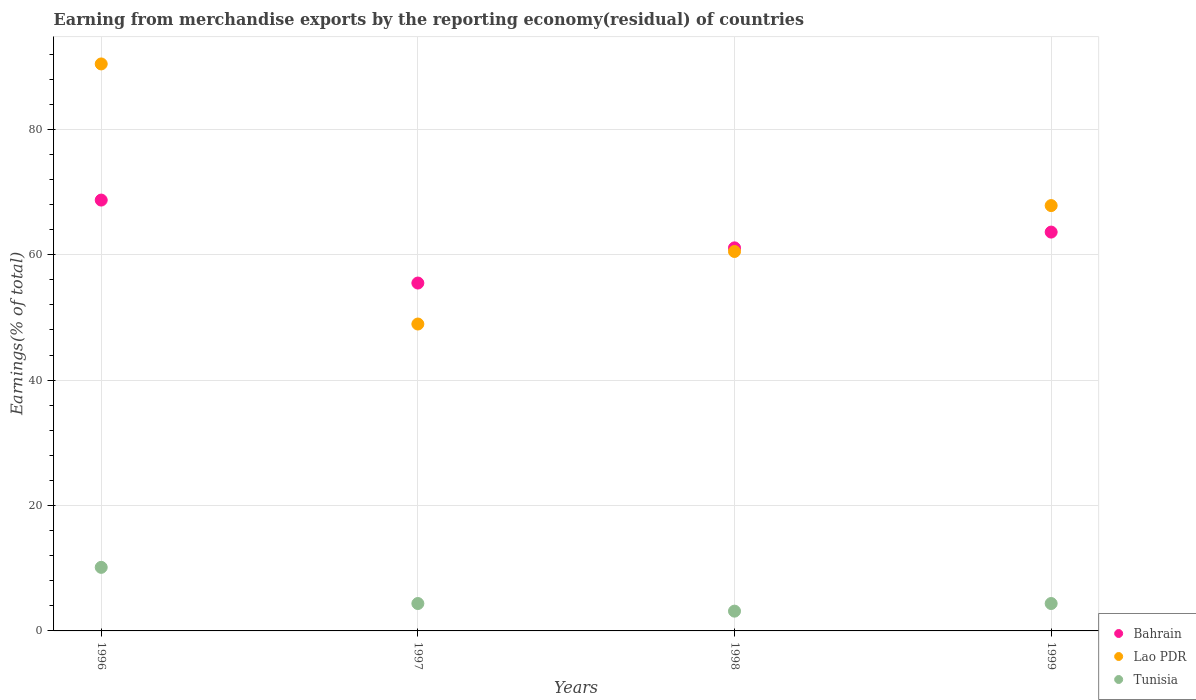What is the percentage of amount earned from merchandise exports in Lao PDR in 1996?
Your answer should be very brief. 90.43. Across all years, what is the maximum percentage of amount earned from merchandise exports in Lao PDR?
Your answer should be compact. 90.43. Across all years, what is the minimum percentage of amount earned from merchandise exports in Lao PDR?
Your answer should be very brief. 48.95. In which year was the percentage of amount earned from merchandise exports in Bahrain maximum?
Make the answer very short. 1996. In which year was the percentage of amount earned from merchandise exports in Bahrain minimum?
Keep it short and to the point. 1997. What is the total percentage of amount earned from merchandise exports in Lao PDR in the graph?
Keep it short and to the point. 267.72. What is the difference between the percentage of amount earned from merchandise exports in Tunisia in 1997 and that in 1998?
Give a very brief answer. 1.22. What is the difference between the percentage of amount earned from merchandise exports in Tunisia in 1997 and the percentage of amount earned from merchandise exports in Lao PDR in 1999?
Make the answer very short. -63.47. What is the average percentage of amount earned from merchandise exports in Tunisia per year?
Your response must be concise. 5.51. In the year 1998, what is the difference between the percentage of amount earned from merchandise exports in Tunisia and percentage of amount earned from merchandise exports in Bahrain?
Give a very brief answer. -57.94. What is the ratio of the percentage of amount earned from merchandise exports in Tunisia in 1997 to that in 1998?
Keep it short and to the point. 1.39. What is the difference between the highest and the second highest percentage of amount earned from merchandise exports in Bahrain?
Provide a succinct answer. 5.11. What is the difference between the highest and the lowest percentage of amount earned from merchandise exports in Tunisia?
Your response must be concise. 6.98. In how many years, is the percentage of amount earned from merchandise exports in Lao PDR greater than the average percentage of amount earned from merchandise exports in Lao PDR taken over all years?
Ensure brevity in your answer.  2. Is the percentage of amount earned from merchandise exports in Tunisia strictly greater than the percentage of amount earned from merchandise exports in Lao PDR over the years?
Provide a succinct answer. No. Is the percentage of amount earned from merchandise exports in Tunisia strictly less than the percentage of amount earned from merchandise exports in Bahrain over the years?
Ensure brevity in your answer.  Yes. Are the values on the major ticks of Y-axis written in scientific E-notation?
Provide a short and direct response. No. Does the graph contain any zero values?
Keep it short and to the point. No. How are the legend labels stacked?
Give a very brief answer. Vertical. What is the title of the graph?
Your answer should be very brief. Earning from merchandise exports by the reporting economy(residual) of countries. Does "Madagascar" appear as one of the legend labels in the graph?
Your answer should be compact. No. What is the label or title of the X-axis?
Offer a terse response. Years. What is the label or title of the Y-axis?
Make the answer very short. Earnings(% of total). What is the Earnings(% of total) in Bahrain in 1996?
Keep it short and to the point. 68.71. What is the Earnings(% of total) of Lao PDR in 1996?
Provide a short and direct response. 90.43. What is the Earnings(% of total) of Tunisia in 1996?
Offer a very short reply. 10.14. What is the Earnings(% of total) of Bahrain in 1997?
Your answer should be compact. 55.48. What is the Earnings(% of total) in Lao PDR in 1997?
Make the answer very short. 48.95. What is the Earnings(% of total) of Tunisia in 1997?
Ensure brevity in your answer.  4.37. What is the Earnings(% of total) in Bahrain in 1998?
Offer a very short reply. 61.09. What is the Earnings(% of total) in Lao PDR in 1998?
Your answer should be very brief. 60.52. What is the Earnings(% of total) in Tunisia in 1998?
Your answer should be very brief. 3.15. What is the Earnings(% of total) of Bahrain in 1999?
Provide a succinct answer. 63.61. What is the Earnings(% of total) in Lao PDR in 1999?
Offer a very short reply. 67.84. What is the Earnings(% of total) of Tunisia in 1999?
Keep it short and to the point. 4.37. Across all years, what is the maximum Earnings(% of total) in Bahrain?
Give a very brief answer. 68.71. Across all years, what is the maximum Earnings(% of total) of Lao PDR?
Offer a terse response. 90.43. Across all years, what is the maximum Earnings(% of total) of Tunisia?
Your answer should be very brief. 10.14. Across all years, what is the minimum Earnings(% of total) of Bahrain?
Give a very brief answer. 55.48. Across all years, what is the minimum Earnings(% of total) in Lao PDR?
Give a very brief answer. 48.95. Across all years, what is the minimum Earnings(% of total) of Tunisia?
Keep it short and to the point. 3.15. What is the total Earnings(% of total) in Bahrain in the graph?
Make the answer very short. 248.9. What is the total Earnings(% of total) in Lao PDR in the graph?
Provide a short and direct response. 267.72. What is the total Earnings(% of total) of Tunisia in the graph?
Offer a very short reply. 22.03. What is the difference between the Earnings(% of total) in Bahrain in 1996 and that in 1997?
Your answer should be compact. 13.23. What is the difference between the Earnings(% of total) of Lao PDR in 1996 and that in 1997?
Provide a succinct answer. 41.48. What is the difference between the Earnings(% of total) in Tunisia in 1996 and that in 1997?
Offer a very short reply. 5.77. What is the difference between the Earnings(% of total) of Bahrain in 1996 and that in 1998?
Offer a very short reply. 7.62. What is the difference between the Earnings(% of total) in Lao PDR in 1996 and that in 1998?
Offer a terse response. 29.91. What is the difference between the Earnings(% of total) of Tunisia in 1996 and that in 1998?
Offer a terse response. 6.98. What is the difference between the Earnings(% of total) of Bahrain in 1996 and that in 1999?
Your response must be concise. 5.11. What is the difference between the Earnings(% of total) in Lao PDR in 1996 and that in 1999?
Your response must be concise. 22.59. What is the difference between the Earnings(% of total) in Tunisia in 1996 and that in 1999?
Keep it short and to the point. 5.77. What is the difference between the Earnings(% of total) of Bahrain in 1997 and that in 1998?
Provide a succinct answer. -5.61. What is the difference between the Earnings(% of total) in Lao PDR in 1997 and that in 1998?
Provide a succinct answer. -11.57. What is the difference between the Earnings(% of total) of Tunisia in 1997 and that in 1998?
Your answer should be very brief. 1.22. What is the difference between the Earnings(% of total) in Bahrain in 1997 and that in 1999?
Ensure brevity in your answer.  -8.13. What is the difference between the Earnings(% of total) of Lao PDR in 1997 and that in 1999?
Offer a terse response. -18.89. What is the difference between the Earnings(% of total) in Tunisia in 1997 and that in 1999?
Your answer should be compact. -0. What is the difference between the Earnings(% of total) of Bahrain in 1998 and that in 1999?
Offer a terse response. -2.52. What is the difference between the Earnings(% of total) of Lao PDR in 1998 and that in 1999?
Your answer should be compact. -7.32. What is the difference between the Earnings(% of total) of Tunisia in 1998 and that in 1999?
Make the answer very short. -1.22. What is the difference between the Earnings(% of total) in Bahrain in 1996 and the Earnings(% of total) in Lao PDR in 1997?
Ensure brevity in your answer.  19.77. What is the difference between the Earnings(% of total) in Bahrain in 1996 and the Earnings(% of total) in Tunisia in 1997?
Give a very brief answer. 64.35. What is the difference between the Earnings(% of total) in Lao PDR in 1996 and the Earnings(% of total) in Tunisia in 1997?
Provide a short and direct response. 86.06. What is the difference between the Earnings(% of total) of Bahrain in 1996 and the Earnings(% of total) of Lao PDR in 1998?
Your answer should be compact. 8.2. What is the difference between the Earnings(% of total) in Bahrain in 1996 and the Earnings(% of total) in Tunisia in 1998?
Offer a terse response. 65.56. What is the difference between the Earnings(% of total) in Lao PDR in 1996 and the Earnings(% of total) in Tunisia in 1998?
Your answer should be very brief. 87.27. What is the difference between the Earnings(% of total) of Bahrain in 1996 and the Earnings(% of total) of Lao PDR in 1999?
Make the answer very short. 0.88. What is the difference between the Earnings(% of total) of Bahrain in 1996 and the Earnings(% of total) of Tunisia in 1999?
Your answer should be compact. 64.34. What is the difference between the Earnings(% of total) of Lao PDR in 1996 and the Earnings(% of total) of Tunisia in 1999?
Offer a very short reply. 86.06. What is the difference between the Earnings(% of total) in Bahrain in 1997 and the Earnings(% of total) in Lao PDR in 1998?
Ensure brevity in your answer.  -5.03. What is the difference between the Earnings(% of total) in Bahrain in 1997 and the Earnings(% of total) in Tunisia in 1998?
Ensure brevity in your answer.  52.33. What is the difference between the Earnings(% of total) in Lao PDR in 1997 and the Earnings(% of total) in Tunisia in 1998?
Provide a short and direct response. 45.79. What is the difference between the Earnings(% of total) of Bahrain in 1997 and the Earnings(% of total) of Lao PDR in 1999?
Your answer should be very brief. -12.35. What is the difference between the Earnings(% of total) of Bahrain in 1997 and the Earnings(% of total) of Tunisia in 1999?
Provide a short and direct response. 51.11. What is the difference between the Earnings(% of total) in Lao PDR in 1997 and the Earnings(% of total) in Tunisia in 1999?
Offer a very short reply. 44.58. What is the difference between the Earnings(% of total) in Bahrain in 1998 and the Earnings(% of total) in Lao PDR in 1999?
Ensure brevity in your answer.  -6.74. What is the difference between the Earnings(% of total) of Bahrain in 1998 and the Earnings(% of total) of Tunisia in 1999?
Offer a terse response. 56.72. What is the difference between the Earnings(% of total) of Lao PDR in 1998 and the Earnings(% of total) of Tunisia in 1999?
Your answer should be compact. 56.15. What is the average Earnings(% of total) of Bahrain per year?
Offer a very short reply. 62.23. What is the average Earnings(% of total) in Lao PDR per year?
Keep it short and to the point. 66.93. What is the average Earnings(% of total) in Tunisia per year?
Offer a very short reply. 5.51. In the year 1996, what is the difference between the Earnings(% of total) of Bahrain and Earnings(% of total) of Lao PDR?
Your response must be concise. -21.71. In the year 1996, what is the difference between the Earnings(% of total) of Bahrain and Earnings(% of total) of Tunisia?
Your answer should be very brief. 58.58. In the year 1996, what is the difference between the Earnings(% of total) in Lao PDR and Earnings(% of total) in Tunisia?
Keep it short and to the point. 80.29. In the year 1997, what is the difference between the Earnings(% of total) in Bahrain and Earnings(% of total) in Lao PDR?
Provide a succinct answer. 6.54. In the year 1997, what is the difference between the Earnings(% of total) in Bahrain and Earnings(% of total) in Tunisia?
Make the answer very short. 51.11. In the year 1997, what is the difference between the Earnings(% of total) of Lao PDR and Earnings(% of total) of Tunisia?
Ensure brevity in your answer.  44.58. In the year 1998, what is the difference between the Earnings(% of total) of Bahrain and Earnings(% of total) of Lao PDR?
Offer a very short reply. 0.58. In the year 1998, what is the difference between the Earnings(% of total) of Bahrain and Earnings(% of total) of Tunisia?
Your answer should be very brief. 57.94. In the year 1998, what is the difference between the Earnings(% of total) in Lao PDR and Earnings(% of total) in Tunisia?
Offer a very short reply. 57.36. In the year 1999, what is the difference between the Earnings(% of total) in Bahrain and Earnings(% of total) in Lao PDR?
Ensure brevity in your answer.  -4.23. In the year 1999, what is the difference between the Earnings(% of total) in Bahrain and Earnings(% of total) in Tunisia?
Give a very brief answer. 59.24. In the year 1999, what is the difference between the Earnings(% of total) of Lao PDR and Earnings(% of total) of Tunisia?
Keep it short and to the point. 63.47. What is the ratio of the Earnings(% of total) of Bahrain in 1996 to that in 1997?
Offer a terse response. 1.24. What is the ratio of the Earnings(% of total) in Lao PDR in 1996 to that in 1997?
Offer a terse response. 1.85. What is the ratio of the Earnings(% of total) in Tunisia in 1996 to that in 1997?
Provide a succinct answer. 2.32. What is the ratio of the Earnings(% of total) in Bahrain in 1996 to that in 1998?
Your answer should be very brief. 1.12. What is the ratio of the Earnings(% of total) in Lao PDR in 1996 to that in 1998?
Ensure brevity in your answer.  1.49. What is the ratio of the Earnings(% of total) of Tunisia in 1996 to that in 1998?
Offer a terse response. 3.21. What is the ratio of the Earnings(% of total) in Bahrain in 1996 to that in 1999?
Your answer should be very brief. 1.08. What is the ratio of the Earnings(% of total) of Lao PDR in 1996 to that in 1999?
Your answer should be compact. 1.33. What is the ratio of the Earnings(% of total) of Tunisia in 1996 to that in 1999?
Provide a short and direct response. 2.32. What is the ratio of the Earnings(% of total) in Bahrain in 1997 to that in 1998?
Make the answer very short. 0.91. What is the ratio of the Earnings(% of total) in Lao PDR in 1997 to that in 1998?
Your answer should be compact. 0.81. What is the ratio of the Earnings(% of total) in Tunisia in 1997 to that in 1998?
Your answer should be very brief. 1.39. What is the ratio of the Earnings(% of total) of Bahrain in 1997 to that in 1999?
Provide a short and direct response. 0.87. What is the ratio of the Earnings(% of total) in Lao PDR in 1997 to that in 1999?
Give a very brief answer. 0.72. What is the ratio of the Earnings(% of total) of Tunisia in 1997 to that in 1999?
Ensure brevity in your answer.  1. What is the ratio of the Earnings(% of total) of Bahrain in 1998 to that in 1999?
Your response must be concise. 0.96. What is the ratio of the Earnings(% of total) of Lao PDR in 1998 to that in 1999?
Offer a terse response. 0.89. What is the ratio of the Earnings(% of total) of Tunisia in 1998 to that in 1999?
Ensure brevity in your answer.  0.72. What is the difference between the highest and the second highest Earnings(% of total) of Bahrain?
Provide a short and direct response. 5.11. What is the difference between the highest and the second highest Earnings(% of total) in Lao PDR?
Provide a succinct answer. 22.59. What is the difference between the highest and the second highest Earnings(% of total) of Tunisia?
Provide a short and direct response. 5.77. What is the difference between the highest and the lowest Earnings(% of total) of Bahrain?
Give a very brief answer. 13.23. What is the difference between the highest and the lowest Earnings(% of total) of Lao PDR?
Offer a terse response. 41.48. What is the difference between the highest and the lowest Earnings(% of total) in Tunisia?
Make the answer very short. 6.98. 